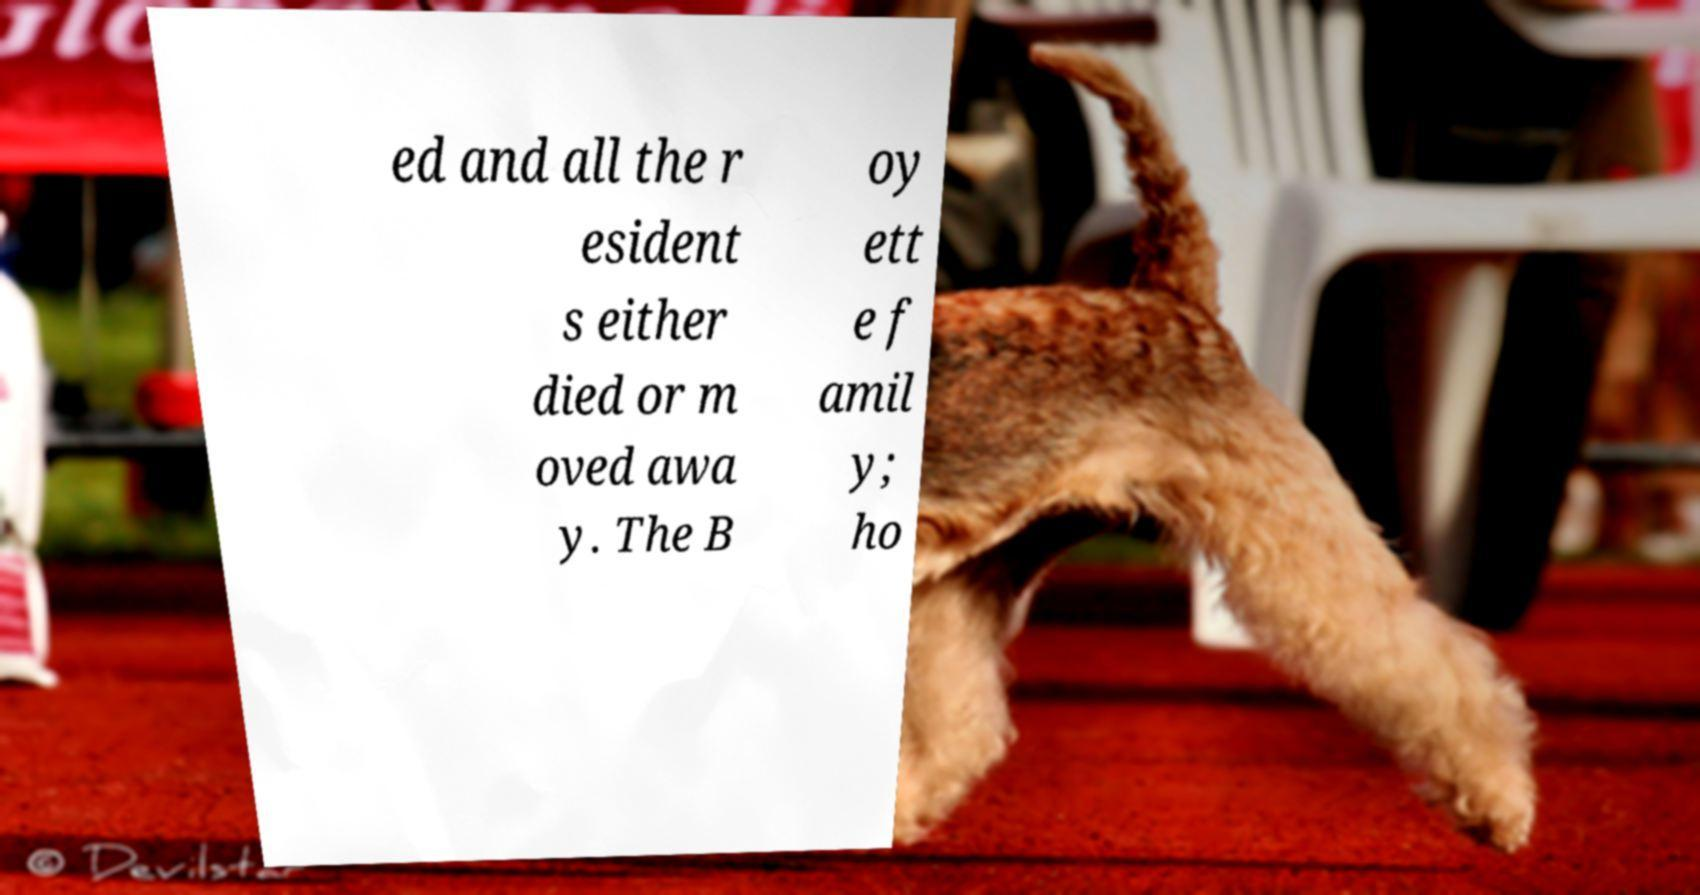What messages or text are displayed in this image? I need them in a readable, typed format. ed and all the r esident s either died or m oved awa y. The B oy ett e f amil y; ho 